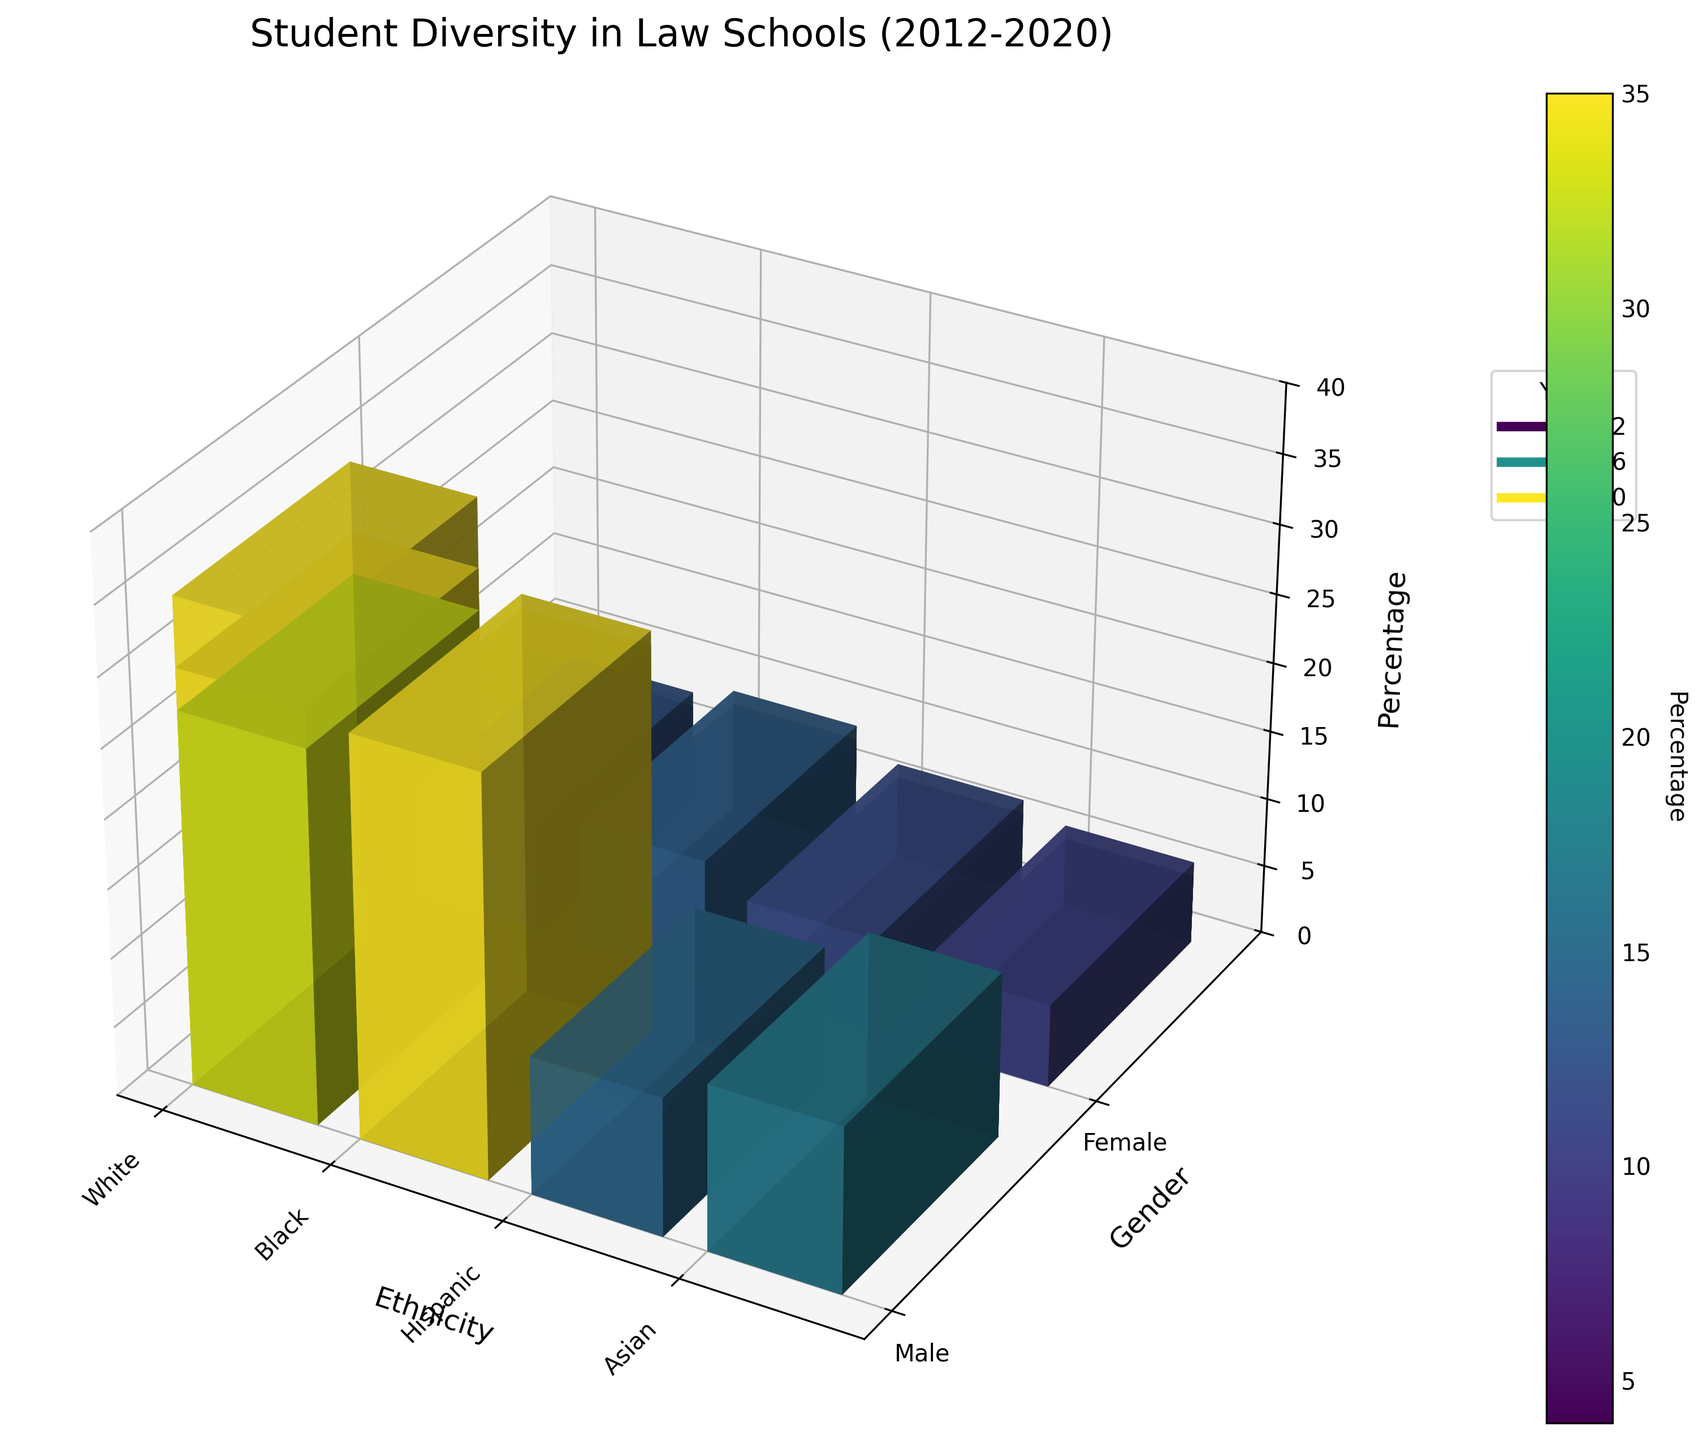What is the title of the figure? The title is generally located at the top of a plot or graph. In this case, it should be straightforward since it is written as text.
Answer: Student Diversity in Law Schools (2012-2020) What are the different ethnicities represented in the plot? Observing the tick labels on the x-axis should give the names of all ethnicities.
Answer: White, Black, Hispanic, Asian What is the percentage of Hispanic females in the year 2016? Find the bar corresponding to Hispanic females (Middle Class) for the year 2016 in the 3D plot and read the height of the bar.
Answer: 8% Which gender has a higher percentage among Black students in 2020? Compare the heights of the bars for Black males and Black females in 2020.
Answer: Female How has the percentage of White males changed from 2012 to 2020? Note the height of the bars for White males in 2012 and 2020, then observe the change.
Answer: Decreased from 35% to 27% What ethnicity has the lowest representation among upper-class students in 2012? Compare the heights of the bars for all ethnicities among upper-class students in 2012.
Answer: Asian What is the average percentage of Hispanic students (both male and female) in 2020? Identify and sum the percentages for Hispanic males and females in 2020, then divide by 2 to get the average. (8% + 9%) / 2 = 8.5
Answer: 8.5% In which year do White females have the highest recorded percentage? Compare the heights of the bars for White females across all years.
Answer: 2020 What trends can you observe about Asian students' representation from 2012 to 2020? Look at the year-by-year data for both Asian males and females and note any changes in bar height.
Answer: Gradual increase Which year shows the highest overall diversity (smallest percentage for the majority ethnicity)? Compare the bar heights for the majority ethnicity (White Males) across all years and determine the year with the lowest height.
Answer: 2020 